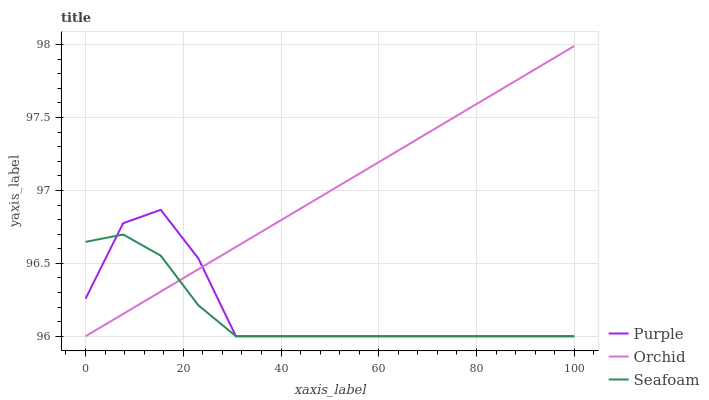Does Orchid have the minimum area under the curve?
Answer yes or no. No. Does Seafoam have the maximum area under the curve?
Answer yes or no. No. Is Seafoam the smoothest?
Answer yes or no. No. Is Seafoam the roughest?
Answer yes or no. No. Does Seafoam have the highest value?
Answer yes or no. No. 